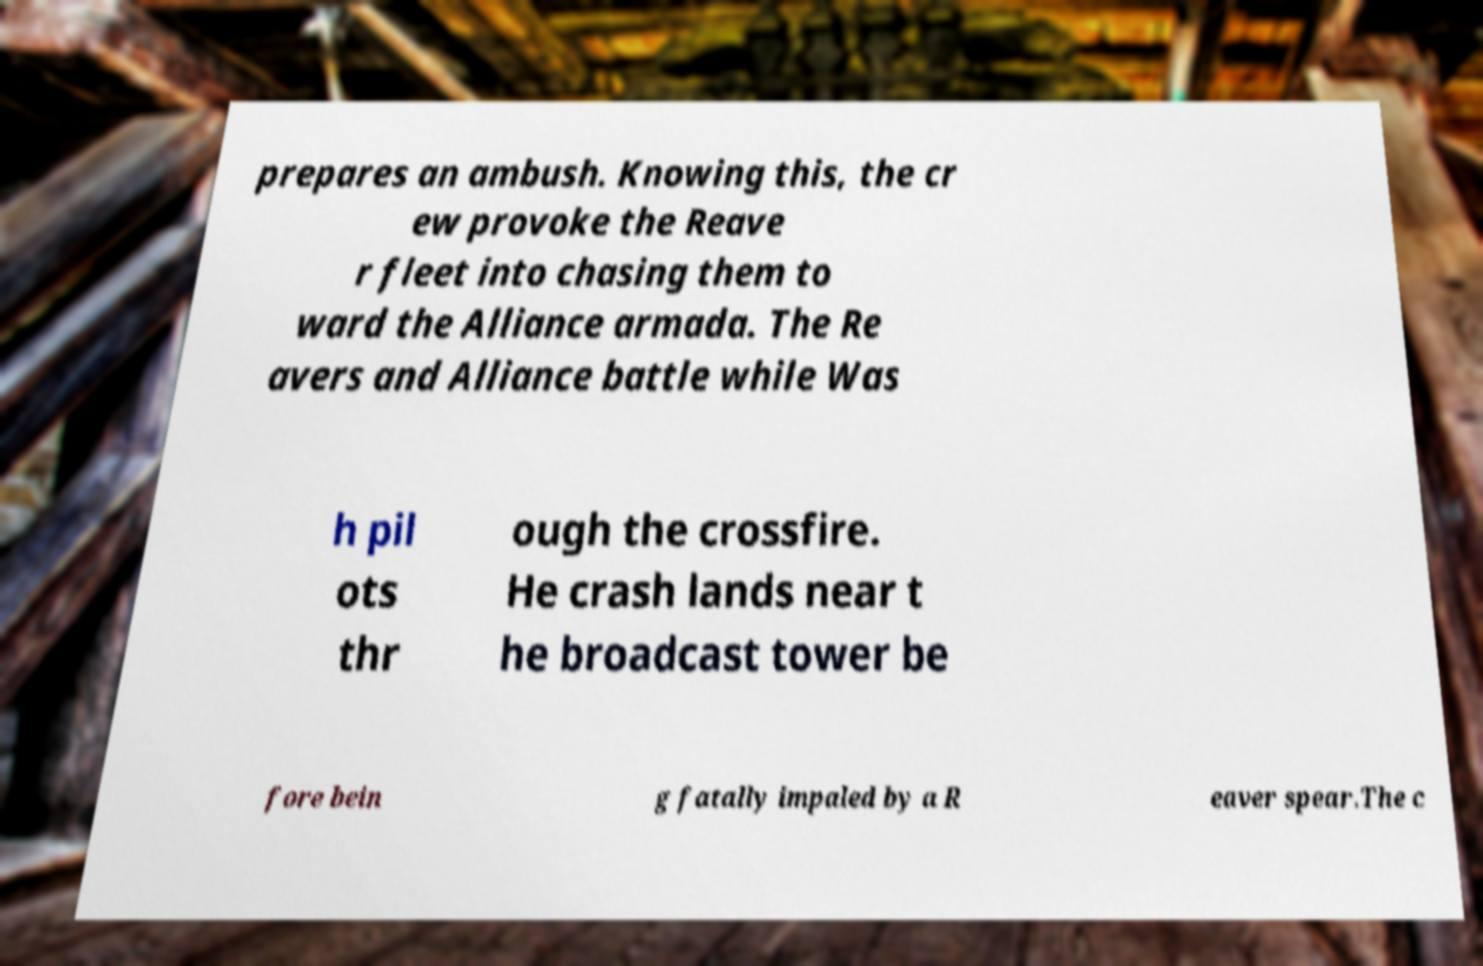Please read and relay the text visible in this image. What does it say? prepares an ambush. Knowing this, the cr ew provoke the Reave r fleet into chasing them to ward the Alliance armada. The Re avers and Alliance battle while Was h pil ots thr ough the crossfire. He crash lands near t he broadcast tower be fore bein g fatally impaled by a R eaver spear.The c 